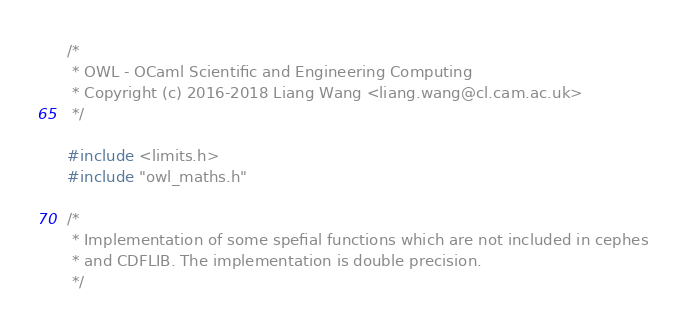Convert code to text. <code><loc_0><loc_0><loc_500><loc_500><_C_>/*
 * OWL - OCaml Scientific and Engineering Computing
 * Copyright (c) 2016-2018 Liang Wang <liang.wang@cl.cam.ac.uk>
 */

#include <limits.h>
#include "owl_maths.h"

/*
 * Implementation of some spefial functions which are not included in cephes
 * and CDFLIB. The implementation is double precision.
 */

</code> 